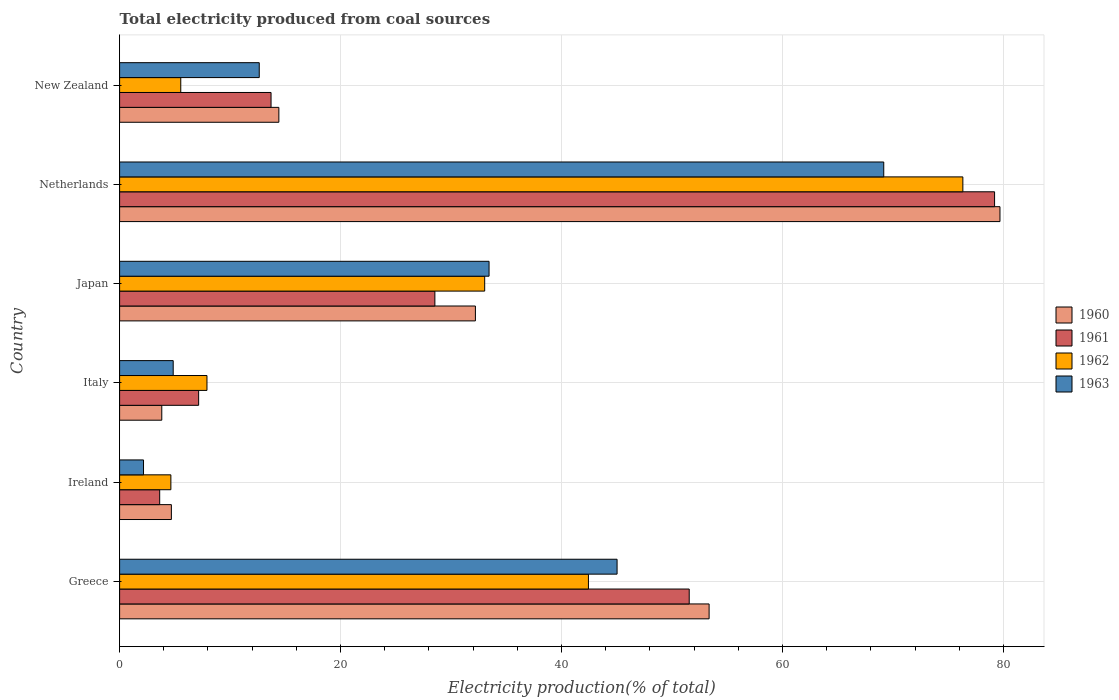Are the number of bars per tick equal to the number of legend labels?
Keep it short and to the point. Yes. Are the number of bars on each tick of the Y-axis equal?
Keep it short and to the point. Yes. How many bars are there on the 6th tick from the top?
Your answer should be very brief. 4. What is the label of the 5th group of bars from the top?
Ensure brevity in your answer.  Ireland. In how many cases, is the number of bars for a given country not equal to the number of legend labels?
Keep it short and to the point. 0. What is the total electricity produced in 1960 in Japan?
Provide a succinct answer. 32.21. Across all countries, what is the maximum total electricity produced in 1961?
Provide a succinct answer. 79.2. Across all countries, what is the minimum total electricity produced in 1961?
Your response must be concise. 3.63. In which country was the total electricity produced in 1960 maximum?
Your answer should be compact. Netherlands. In which country was the total electricity produced in 1960 minimum?
Your answer should be very brief. Italy. What is the total total electricity produced in 1961 in the graph?
Offer a very short reply. 183.8. What is the difference between the total electricity produced in 1961 in Ireland and that in Japan?
Ensure brevity in your answer.  -24.91. What is the difference between the total electricity produced in 1962 in Ireland and the total electricity produced in 1963 in Italy?
Your response must be concise. -0.21. What is the average total electricity produced in 1962 per country?
Keep it short and to the point. 28.32. What is the difference between the total electricity produced in 1961 and total electricity produced in 1963 in New Zealand?
Give a very brief answer. 1.07. In how many countries, is the total electricity produced in 1963 greater than 48 %?
Your answer should be compact. 1. What is the ratio of the total electricity produced in 1962 in Netherlands to that in New Zealand?
Make the answer very short. 13.79. Is the difference between the total electricity produced in 1961 in Greece and Ireland greater than the difference between the total electricity produced in 1963 in Greece and Ireland?
Your response must be concise. Yes. What is the difference between the highest and the second highest total electricity produced in 1961?
Your answer should be very brief. 27.64. What is the difference between the highest and the lowest total electricity produced in 1963?
Keep it short and to the point. 67.01. In how many countries, is the total electricity produced in 1962 greater than the average total electricity produced in 1962 taken over all countries?
Provide a short and direct response. 3. Is it the case that in every country, the sum of the total electricity produced in 1960 and total electricity produced in 1961 is greater than the sum of total electricity produced in 1963 and total electricity produced in 1962?
Ensure brevity in your answer.  No. What does the 3rd bar from the top in Japan represents?
Offer a very short reply. 1961. What does the 1st bar from the bottom in Japan represents?
Offer a very short reply. 1960. Is it the case that in every country, the sum of the total electricity produced in 1962 and total electricity produced in 1961 is greater than the total electricity produced in 1963?
Provide a succinct answer. Yes. How many bars are there?
Your response must be concise. 24. How many countries are there in the graph?
Offer a very short reply. 6. Does the graph contain any zero values?
Provide a short and direct response. No. Does the graph contain grids?
Your response must be concise. Yes. Where does the legend appear in the graph?
Give a very brief answer. Center right. How are the legend labels stacked?
Offer a very short reply. Vertical. What is the title of the graph?
Your answer should be compact. Total electricity produced from coal sources. What is the label or title of the X-axis?
Your answer should be very brief. Electricity production(% of total). What is the label or title of the Y-axis?
Offer a terse response. Country. What is the Electricity production(% of total) in 1960 in Greece?
Keep it short and to the point. 53.36. What is the Electricity production(% of total) of 1961 in Greece?
Make the answer very short. 51.56. What is the Electricity production(% of total) in 1962 in Greece?
Ensure brevity in your answer.  42.44. What is the Electricity production(% of total) of 1963 in Greece?
Keep it short and to the point. 45.03. What is the Electricity production(% of total) of 1960 in Ireland?
Your answer should be compact. 4.69. What is the Electricity production(% of total) in 1961 in Ireland?
Offer a very short reply. 3.63. What is the Electricity production(% of total) of 1962 in Ireland?
Your response must be concise. 4.64. What is the Electricity production(% of total) of 1963 in Ireland?
Keep it short and to the point. 2.16. What is the Electricity production(% of total) in 1960 in Italy?
Make the answer very short. 3.82. What is the Electricity production(% of total) in 1961 in Italy?
Keep it short and to the point. 7.15. What is the Electricity production(% of total) of 1962 in Italy?
Ensure brevity in your answer.  7.91. What is the Electricity production(% of total) in 1963 in Italy?
Your answer should be very brief. 4.85. What is the Electricity production(% of total) in 1960 in Japan?
Your answer should be very brief. 32.21. What is the Electricity production(% of total) of 1961 in Japan?
Give a very brief answer. 28.54. What is the Electricity production(% of total) of 1962 in Japan?
Keep it short and to the point. 33.05. What is the Electricity production(% of total) of 1963 in Japan?
Give a very brief answer. 33.44. What is the Electricity production(% of total) of 1960 in Netherlands?
Keep it short and to the point. 79.69. What is the Electricity production(% of total) in 1961 in Netherlands?
Your response must be concise. 79.2. What is the Electricity production(% of total) in 1962 in Netherlands?
Your response must be concise. 76.33. What is the Electricity production(% of total) of 1963 in Netherlands?
Keep it short and to the point. 69.17. What is the Electricity production(% of total) of 1960 in New Zealand?
Give a very brief answer. 14.42. What is the Electricity production(% of total) in 1961 in New Zealand?
Provide a short and direct response. 13.71. What is the Electricity production(% of total) of 1962 in New Zealand?
Provide a succinct answer. 5.54. What is the Electricity production(% of total) in 1963 in New Zealand?
Your answer should be very brief. 12.64. Across all countries, what is the maximum Electricity production(% of total) of 1960?
Offer a very short reply. 79.69. Across all countries, what is the maximum Electricity production(% of total) of 1961?
Keep it short and to the point. 79.2. Across all countries, what is the maximum Electricity production(% of total) of 1962?
Offer a terse response. 76.33. Across all countries, what is the maximum Electricity production(% of total) of 1963?
Offer a terse response. 69.17. Across all countries, what is the minimum Electricity production(% of total) in 1960?
Keep it short and to the point. 3.82. Across all countries, what is the minimum Electricity production(% of total) in 1961?
Your response must be concise. 3.63. Across all countries, what is the minimum Electricity production(% of total) of 1962?
Keep it short and to the point. 4.64. Across all countries, what is the minimum Electricity production(% of total) of 1963?
Your answer should be very brief. 2.16. What is the total Electricity production(% of total) in 1960 in the graph?
Keep it short and to the point. 188.18. What is the total Electricity production(% of total) of 1961 in the graph?
Provide a succinct answer. 183.8. What is the total Electricity production(% of total) in 1962 in the graph?
Provide a succinct answer. 169.91. What is the total Electricity production(% of total) of 1963 in the graph?
Give a very brief answer. 167.3. What is the difference between the Electricity production(% of total) in 1960 in Greece and that in Ireland?
Your answer should be compact. 48.68. What is the difference between the Electricity production(% of total) in 1961 in Greece and that in Ireland?
Ensure brevity in your answer.  47.93. What is the difference between the Electricity production(% of total) in 1962 in Greece and that in Ireland?
Your answer should be very brief. 37.8. What is the difference between the Electricity production(% of total) of 1963 in Greece and that in Ireland?
Your answer should be compact. 42.87. What is the difference between the Electricity production(% of total) in 1960 in Greece and that in Italy?
Offer a terse response. 49.54. What is the difference between the Electricity production(% of total) in 1961 in Greece and that in Italy?
Your answer should be compact. 44.41. What is the difference between the Electricity production(% of total) of 1962 in Greece and that in Italy?
Offer a very short reply. 34.53. What is the difference between the Electricity production(% of total) of 1963 in Greece and that in Italy?
Your response must be concise. 40.18. What is the difference between the Electricity production(% of total) in 1960 in Greece and that in Japan?
Keep it short and to the point. 21.15. What is the difference between the Electricity production(% of total) in 1961 in Greece and that in Japan?
Ensure brevity in your answer.  23.02. What is the difference between the Electricity production(% of total) in 1962 in Greece and that in Japan?
Offer a terse response. 9.39. What is the difference between the Electricity production(% of total) in 1963 in Greece and that in Japan?
Ensure brevity in your answer.  11.59. What is the difference between the Electricity production(% of total) in 1960 in Greece and that in Netherlands?
Ensure brevity in your answer.  -26.33. What is the difference between the Electricity production(% of total) of 1961 in Greece and that in Netherlands?
Ensure brevity in your answer.  -27.64. What is the difference between the Electricity production(% of total) in 1962 in Greece and that in Netherlands?
Give a very brief answer. -33.89. What is the difference between the Electricity production(% of total) of 1963 in Greece and that in Netherlands?
Make the answer very short. -24.14. What is the difference between the Electricity production(% of total) in 1960 in Greece and that in New Zealand?
Ensure brevity in your answer.  38.95. What is the difference between the Electricity production(% of total) of 1961 in Greece and that in New Zealand?
Offer a terse response. 37.85. What is the difference between the Electricity production(% of total) of 1962 in Greece and that in New Zealand?
Offer a very short reply. 36.9. What is the difference between the Electricity production(% of total) in 1963 in Greece and that in New Zealand?
Give a very brief answer. 32.39. What is the difference between the Electricity production(% of total) in 1960 in Ireland and that in Italy?
Your answer should be compact. 0.87. What is the difference between the Electricity production(% of total) in 1961 in Ireland and that in Italy?
Your response must be concise. -3.53. What is the difference between the Electricity production(% of total) in 1962 in Ireland and that in Italy?
Your answer should be compact. -3.27. What is the difference between the Electricity production(% of total) in 1963 in Ireland and that in Italy?
Provide a short and direct response. -2.69. What is the difference between the Electricity production(% of total) in 1960 in Ireland and that in Japan?
Offer a terse response. -27.52. What is the difference between the Electricity production(% of total) in 1961 in Ireland and that in Japan?
Provide a succinct answer. -24.91. What is the difference between the Electricity production(% of total) of 1962 in Ireland and that in Japan?
Offer a very short reply. -28.41. What is the difference between the Electricity production(% of total) in 1963 in Ireland and that in Japan?
Provide a short and direct response. -31.28. What is the difference between the Electricity production(% of total) of 1960 in Ireland and that in Netherlands?
Your response must be concise. -75.01. What is the difference between the Electricity production(% of total) in 1961 in Ireland and that in Netherlands?
Provide a succinct answer. -75.58. What is the difference between the Electricity production(% of total) of 1962 in Ireland and that in Netherlands?
Your response must be concise. -71.69. What is the difference between the Electricity production(% of total) of 1963 in Ireland and that in Netherlands?
Offer a terse response. -67.01. What is the difference between the Electricity production(% of total) in 1960 in Ireland and that in New Zealand?
Your answer should be compact. -9.73. What is the difference between the Electricity production(% of total) of 1961 in Ireland and that in New Zealand?
Offer a very short reply. -10.08. What is the difference between the Electricity production(% of total) of 1962 in Ireland and that in New Zealand?
Your answer should be very brief. -0.9. What is the difference between the Electricity production(% of total) in 1963 in Ireland and that in New Zealand?
Your response must be concise. -10.48. What is the difference between the Electricity production(% of total) of 1960 in Italy and that in Japan?
Provide a short and direct response. -28.39. What is the difference between the Electricity production(% of total) of 1961 in Italy and that in Japan?
Offer a very short reply. -21.38. What is the difference between the Electricity production(% of total) in 1962 in Italy and that in Japan?
Make the answer very short. -25.14. What is the difference between the Electricity production(% of total) in 1963 in Italy and that in Japan?
Make the answer very short. -28.59. What is the difference between the Electricity production(% of total) in 1960 in Italy and that in Netherlands?
Provide a short and direct response. -75.87. What is the difference between the Electricity production(% of total) in 1961 in Italy and that in Netherlands?
Provide a succinct answer. -72.05. What is the difference between the Electricity production(% of total) of 1962 in Italy and that in Netherlands?
Offer a terse response. -68.42. What is the difference between the Electricity production(% of total) of 1963 in Italy and that in Netherlands?
Your answer should be very brief. -64.32. What is the difference between the Electricity production(% of total) in 1960 in Italy and that in New Zealand?
Offer a very short reply. -10.6. What is the difference between the Electricity production(% of total) of 1961 in Italy and that in New Zealand?
Your response must be concise. -6.55. What is the difference between the Electricity production(% of total) of 1962 in Italy and that in New Zealand?
Your answer should be compact. 2.37. What is the difference between the Electricity production(% of total) of 1963 in Italy and that in New Zealand?
Your response must be concise. -7.79. What is the difference between the Electricity production(% of total) of 1960 in Japan and that in Netherlands?
Provide a succinct answer. -47.48. What is the difference between the Electricity production(% of total) of 1961 in Japan and that in Netherlands?
Give a very brief answer. -50.67. What is the difference between the Electricity production(% of total) in 1962 in Japan and that in Netherlands?
Make the answer very short. -43.28. What is the difference between the Electricity production(% of total) in 1963 in Japan and that in Netherlands?
Offer a very short reply. -35.73. What is the difference between the Electricity production(% of total) of 1960 in Japan and that in New Zealand?
Your response must be concise. 17.79. What is the difference between the Electricity production(% of total) in 1961 in Japan and that in New Zealand?
Ensure brevity in your answer.  14.83. What is the difference between the Electricity production(% of total) in 1962 in Japan and that in New Zealand?
Provide a succinct answer. 27.51. What is the difference between the Electricity production(% of total) in 1963 in Japan and that in New Zealand?
Offer a terse response. 20.8. What is the difference between the Electricity production(% of total) of 1960 in Netherlands and that in New Zealand?
Ensure brevity in your answer.  65.28. What is the difference between the Electricity production(% of total) in 1961 in Netherlands and that in New Zealand?
Your answer should be compact. 65.5. What is the difference between the Electricity production(% of total) of 1962 in Netherlands and that in New Zealand?
Make the answer very short. 70.8. What is the difference between the Electricity production(% of total) of 1963 in Netherlands and that in New Zealand?
Make the answer very short. 56.53. What is the difference between the Electricity production(% of total) in 1960 in Greece and the Electricity production(% of total) in 1961 in Ireland?
Keep it short and to the point. 49.73. What is the difference between the Electricity production(% of total) of 1960 in Greece and the Electricity production(% of total) of 1962 in Ireland?
Keep it short and to the point. 48.72. What is the difference between the Electricity production(% of total) of 1960 in Greece and the Electricity production(% of total) of 1963 in Ireland?
Offer a very short reply. 51.2. What is the difference between the Electricity production(% of total) of 1961 in Greece and the Electricity production(% of total) of 1962 in Ireland?
Offer a very short reply. 46.92. What is the difference between the Electricity production(% of total) of 1961 in Greece and the Electricity production(% of total) of 1963 in Ireland?
Your response must be concise. 49.4. What is the difference between the Electricity production(% of total) in 1962 in Greece and the Electricity production(% of total) in 1963 in Ireland?
Ensure brevity in your answer.  40.27. What is the difference between the Electricity production(% of total) of 1960 in Greece and the Electricity production(% of total) of 1961 in Italy?
Offer a terse response. 46.21. What is the difference between the Electricity production(% of total) of 1960 in Greece and the Electricity production(% of total) of 1962 in Italy?
Offer a very short reply. 45.45. What is the difference between the Electricity production(% of total) of 1960 in Greece and the Electricity production(% of total) of 1963 in Italy?
Offer a terse response. 48.51. What is the difference between the Electricity production(% of total) in 1961 in Greece and the Electricity production(% of total) in 1962 in Italy?
Your response must be concise. 43.65. What is the difference between the Electricity production(% of total) in 1961 in Greece and the Electricity production(% of total) in 1963 in Italy?
Keep it short and to the point. 46.71. What is the difference between the Electricity production(% of total) of 1962 in Greece and the Electricity production(% of total) of 1963 in Italy?
Make the answer very short. 37.59. What is the difference between the Electricity production(% of total) in 1960 in Greece and the Electricity production(% of total) in 1961 in Japan?
Give a very brief answer. 24.82. What is the difference between the Electricity production(% of total) in 1960 in Greece and the Electricity production(% of total) in 1962 in Japan?
Make the answer very short. 20.31. What is the difference between the Electricity production(% of total) of 1960 in Greece and the Electricity production(% of total) of 1963 in Japan?
Offer a terse response. 19.92. What is the difference between the Electricity production(% of total) in 1961 in Greece and the Electricity production(% of total) in 1962 in Japan?
Your answer should be very brief. 18.51. What is the difference between the Electricity production(% of total) in 1961 in Greece and the Electricity production(% of total) in 1963 in Japan?
Make the answer very short. 18.12. What is the difference between the Electricity production(% of total) of 1962 in Greece and the Electricity production(% of total) of 1963 in Japan?
Make the answer very short. 9. What is the difference between the Electricity production(% of total) of 1960 in Greece and the Electricity production(% of total) of 1961 in Netherlands?
Your response must be concise. -25.84. What is the difference between the Electricity production(% of total) in 1960 in Greece and the Electricity production(% of total) in 1962 in Netherlands?
Your answer should be compact. -22.97. What is the difference between the Electricity production(% of total) in 1960 in Greece and the Electricity production(% of total) in 1963 in Netherlands?
Offer a very short reply. -15.81. What is the difference between the Electricity production(% of total) in 1961 in Greece and the Electricity production(% of total) in 1962 in Netherlands?
Make the answer very short. -24.77. What is the difference between the Electricity production(% of total) of 1961 in Greece and the Electricity production(% of total) of 1963 in Netherlands?
Provide a succinct answer. -17.61. What is the difference between the Electricity production(% of total) in 1962 in Greece and the Electricity production(% of total) in 1963 in Netherlands?
Your answer should be very brief. -26.73. What is the difference between the Electricity production(% of total) of 1960 in Greece and the Electricity production(% of total) of 1961 in New Zealand?
Provide a short and direct response. 39.65. What is the difference between the Electricity production(% of total) in 1960 in Greece and the Electricity production(% of total) in 1962 in New Zealand?
Offer a very short reply. 47.83. What is the difference between the Electricity production(% of total) in 1960 in Greece and the Electricity production(% of total) in 1963 in New Zealand?
Your answer should be very brief. 40.72. What is the difference between the Electricity production(% of total) of 1961 in Greece and the Electricity production(% of total) of 1962 in New Zealand?
Give a very brief answer. 46.03. What is the difference between the Electricity production(% of total) of 1961 in Greece and the Electricity production(% of total) of 1963 in New Zealand?
Your answer should be compact. 38.92. What is the difference between the Electricity production(% of total) of 1962 in Greece and the Electricity production(% of total) of 1963 in New Zealand?
Your response must be concise. 29.8. What is the difference between the Electricity production(% of total) in 1960 in Ireland and the Electricity production(% of total) in 1961 in Italy?
Your answer should be compact. -2.47. What is the difference between the Electricity production(% of total) of 1960 in Ireland and the Electricity production(% of total) of 1962 in Italy?
Keep it short and to the point. -3.22. What is the difference between the Electricity production(% of total) of 1960 in Ireland and the Electricity production(% of total) of 1963 in Italy?
Offer a very short reply. -0.17. What is the difference between the Electricity production(% of total) in 1961 in Ireland and the Electricity production(% of total) in 1962 in Italy?
Provide a short and direct response. -4.28. What is the difference between the Electricity production(% of total) of 1961 in Ireland and the Electricity production(% of total) of 1963 in Italy?
Your answer should be compact. -1.22. What is the difference between the Electricity production(% of total) of 1962 in Ireland and the Electricity production(% of total) of 1963 in Italy?
Keep it short and to the point. -0.21. What is the difference between the Electricity production(% of total) in 1960 in Ireland and the Electricity production(% of total) in 1961 in Japan?
Make the answer very short. -23.85. What is the difference between the Electricity production(% of total) of 1960 in Ireland and the Electricity production(% of total) of 1962 in Japan?
Your answer should be compact. -28.36. What is the difference between the Electricity production(% of total) of 1960 in Ireland and the Electricity production(% of total) of 1963 in Japan?
Ensure brevity in your answer.  -28.76. What is the difference between the Electricity production(% of total) of 1961 in Ireland and the Electricity production(% of total) of 1962 in Japan?
Your answer should be very brief. -29.42. What is the difference between the Electricity production(% of total) in 1961 in Ireland and the Electricity production(% of total) in 1963 in Japan?
Offer a terse response. -29.82. What is the difference between the Electricity production(% of total) in 1962 in Ireland and the Electricity production(% of total) in 1963 in Japan?
Your response must be concise. -28.8. What is the difference between the Electricity production(% of total) of 1960 in Ireland and the Electricity production(% of total) of 1961 in Netherlands?
Your answer should be very brief. -74.52. What is the difference between the Electricity production(% of total) in 1960 in Ireland and the Electricity production(% of total) in 1962 in Netherlands?
Offer a terse response. -71.65. What is the difference between the Electricity production(% of total) of 1960 in Ireland and the Electricity production(% of total) of 1963 in Netherlands?
Give a very brief answer. -64.49. What is the difference between the Electricity production(% of total) in 1961 in Ireland and the Electricity production(% of total) in 1962 in Netherlands?
Provide a succinct answer. -72.71. What is the difference between the Electricity production(% of total) of 1961 in Ireland and the Electricity production(% of total) of 1963 in Netherlands?
Ensure brevity in your answer.  -65.54. What is the difference between the Electricity production(% of total) in 1962 in Ireland and the Electricity production(% of total) in 1963 in Netherlands?
Provide a succinct answer. -64.53. What is the difference between the Electricity production(% of total) in 1960 in Ireland and the Electricity production(% of total) in 1961 in New Zealand?
Provide a short and direct response. -9.02. What is the difference between the Electricity production(% of total) of 1960 in Ireland and the Electricity production(% of total) of 1962 in New Zealand?
Provide a short and direct response. -0.85. What is the difference between the Electricity production(% of total) of 1960 in Ireland and the Electricity production(% of total) of 1963 in New Zealand?
Keep it short and to the point. -7.95. What is the difference between the Electricity production(% of total) in 1961 in Ireland and the Electricity production(% of total) in 1962 in New Zealand?
Your answer should be very brief. -1.91. What is the difference between the Electricity production(% of total) in 1961 in Ireland and the Electricity production(% of total) in 1963 in New Zealand?
Your answer should be compact. -9.01. What is the difference between the Electricity production(% of total) in 1962 in Ireland and the Electricity production(% of total) in 1963 in New Zealand?
Ensure brevity in your answer.  -8. What is the difference between the Electricity production(% of total) in 1960 in Italy and the Electricity production(% of total) in 1961 in Japan?
Provide a short and direct response. -24.72. What is the difference between the Electricity production(% of total) in 1960 in Italy and the Electricity production(% of total) in 1962 in Japan?
Ensure brevity in your answer.  -29.23. What is the difference between the Electricity production(% of total) in 1960 in Italy and the Electricity production(% of total) in 1963 in Japan?
Your response must be concise. -29.63. What is the difference between the Electricity production(% of total) in 1961 in Italy and the Electricity production(% of total) in 1962 in Japan?
Give a very brief answer. -25.89. What is the difference between the Electricity production(% of total) of 1961 in Italy and the Electricity production(% of total) of 1963 in Japan?
Your answer should be compact. -26.29. What is the difference between the Electricity production(% of total) of 1962 in Italy and the Electricity production(% of total) of 1963 in Japan?
Ensure brevity in your answer.  -25.53. What is the difference between the Electricity production(% of total) in 1960 in Italy and the Electricity production(% of total) in 1961 in Netherlands?
Provide a short and direct response. -75.39. What is the difference between the Electricity production(% of total) in 1960 in Italy and the Electricity production(% of total) in 1962 in Netherlands?
Provide a succinct answer. -72.51. What is the difference between the Electricity production(% of total) of 1960 in Italy and the Electricity production(% of total) of 1963 in Netherlands?
Ensure brevity in your answer.  -65.35. What is the difference between the Electricity production(% of total) in 1961 in Italy and the Electricity production(% of total) in 1962 in Netherlands?
Ensure brevity in your answer.  -69.18. What is the difference between the Electricity production(% of total) of 1961 in Italy and the Electricity production(% of total) of 1963 in Netherlands?
Provide a succinct answer. -62.02. What is the difference between the Electricity production(% of total) in 1962 in Italy and the Electricity production(% of total) in 1963 in Netherlands?
Your response must be concise. -61.26. What is the difference between the Electricity production(% of total) of 1960 in Italy and the Electricity production(% of total) of 1961 in New Zealand?
Make the answer very short. -9.89. What is the difference between the Electricity production(% of total) of 1960 in Italy and the Electricity production(% of total) of 1962 in New Zealand?
Make the answer very short. -1.72. What is the difference between the Electricity production(% of total) of 1960 in Italy and the Electricity production(% of total) of 1963 in New Zealand?
Ensure brevity in your answer.  -8.82. What is the difference between the Electricity production(% of total) in 1961 in Italy and the Electricity production(% of total) in 1962 in New Zealand?
Ensure brevity in your answer.  1.62. What is the difference between the Electricity production(% of total) in 1961 in Italy and the Electricity production(% of total) in 1963 in New Zealand?
Give a very brief answer. -5.49. What is the difference between the Electricity production(% of total) of 1962 in Italy and the Electricity production(% of total) of 1963 in New Zealand?
Ensure brevity in your answer.  -4.73. What is the difference between the Electricity production(% of total) of 1960 in Japan and the Electricity production(% of total) of 1961 in Netherlands?
Provide a succinct answer. -47. What is the difference between the Electricity production(% of total) of 1960 in Japan and the Electricity production(% of total) of 1962 in Netherlands?
Ensure brevity in your answer.  -44.13. What is the difference between the Electricity production(% of total) in 1960 in Japan and the Electricity production(% of total) in 1963 in Netherlands?
Your answer should be very brief. -36.96. What is the difference between the Electricity production(% of total) in 1961 in Japan and the Electricity production(% of total) in 1962 in Netherlands?
Keep it short and to the point. -47.79. What is the difference between the Electricity production(% of total) in 1961 in Japan and the Electricity production(% of total) in 1963 in Netherlands?
Offer a very short reply. -40.63. What is the difference between the Electricity production(% of total) in 1962 in Japan and the Electricity production(% of total) in 1963 in Netherlands?
Ensure brevity in your answer.  -36.12. What is the difference between the Electricity production(% of total) of 1960 in Japan and the Electricity production(% of total) of 1961 in New Zealand?
Provide a short and direct response. 18.5. What is the difference between the Electricity production(% of total) in 1960 in Japan and the Electricity production(% of total) in 1962 in New Zealand?
Your answer should be very brief. 26.67. What is the difference between the Electricity production(% of total) of 1960 in Japan and the Electricity production(% of total) of 1963 in New Zealand?
Offer a very short reply. 19.57. What is the difference between the Electricity production(% of total) in 1961 in Japan and the Electricity production(% of total) in 1962 in New Zealand?
Provide a short and direct response. 23. What is the difference between the Electricity production(% of total) of 1961 in Japan and the Electricity production(% of total) of 1963 in New Zealand?
Offer a very short reply. 15.9. What is the difference between the Electricity production(% of total) in 1962 in Japan and the Electricity production(% of total) in 1963 in New Zealand?
Your answer should be compact. 20.41. What is the difference between the Electricity production(% of total) in 1960 in Netherlands and the Electricity production(% of total) in 1961 in New Zealand?
Your answer should be very brief. 65.98. What is the difference between the Electricity production(% of total) of 1960 in Netherlands and the Electricity production(% of total) of 1962 in New Zealand?
Offer a very short reply. 74.16. What is the difference between the Electricity production(% of total) in 1960 in Netherlands and the Electricity production(% of total) in 1963 in New Zealand?
Give a very brief answer. 67.05. What is the difference between the Electricity production(% of total) in 1961 in Netherlands and the Electricity production(% of total) in 1962 in New Zealand?
Your answer should be very brief. 73.67. What is the difference between the Electricity production(% of total) of 1961 in Netherlands and the Electricity production(% of total) of 1963 in New Zealand?
Keep it short and to the point. 66.56. What is the difference between the Electricity production(% of total) of 1962 in Netherlands and the Electricity production(% of total) of 1963 in New Zealand?
Give a very brief answer. 63.69. What is the average Electricity production(% of total) in 1960 per country?
Offer a very short reply. 31.36. What is the average Electricity production(% of total) of 1961 per country?
Your answer should be very brief. 30.63. What is the average Electricity production(% of total) of 1962 per country?
Offer a terse response. 28.32. What is the average Electricity production(% of total) of 1963 per country?
Give a very brief answer. 27.88. What is the difference between the Electricity production(% of total) of 1960 and Electricity production(% of total) of 1961 in Greece?
Provide a short and direct response. 1.8. What is the difference between the Electricity production(% of total) in 1960 and Electricity production(% of total) in 1962 in Greece?
Provide a succinct answer. 10.92. What is the difference between the Electricity production(% of total) of 1960 and Electricity production(% of total) of 1963 in Greece?
Offer a very short reply. 8.33. What is the difference between the Electricity production(% of total) of 1961 and Electricity production(% of total) of 1962 in Greece?
Give a very brief answer. 9.12. What is the difference between the Electricity production(% of total) of 1961 and Electricity production(% of total) of 1963 in Greece?
Give a very brief answer. 6.53. What is the difference between the Electricity production(% of total) in 1962 and Electricity production(% of total) in 1963 in Greece?
Your answer should be compact. -2.59. What is the difference between the Electricity production(% of total) of 1960 and Electricity production(% of total) of 1961 in Ireland?
Make the answer very short. 1.06. What is the difference between the Electricity production(% of total) in 1960 and Electricity production(% of total) in 1962 in Ireland?
Offer a very short reply. 0.05. What is the difference between the Electricity production(% of total) in 1960 and Electricity production(% of total) in 1963 in Ireland?
Your answer should be compact. 2.52. What is the difference between the Electricity production(% of total) in 1961 and Electricity production(% of total) in 1962 in Ireland?
Make the answer very short. -1.01. What is the difference between the Electricity production(% of total) in 1961 and Electricity production(% of total) in 1963 in Ireland?
Offer a very short reply. 1.46. What is the difference between the Electricity production(% of total) of 1962 and Electricity production(% of total) of 1963 in Ireland?
Offer a very short reply. 2.48. What is the difference between the Electricity production(% of total) of 1960 and Electricity production(% of total) of 1961 in Italy?
Provide a succinct answer. -3.34. What is the difference between the Electricity production(% of total) of 1960 and Electricity production(% of total) of 1962 in Italy?
Your answer should be compact. -4.09. What is the difference between the Electricity production(% of total) of 1960 and Electricity production(% of total) of 1963 in Italy?
Your answer should be compact. -1.03. What is the difference between the Electricity production(% of total) in 1961 and Electricity production(% of total) in 1962 in Italy?
Offer a terse response. -0.75. What is the difference between the Electricity production(% of total) in 1961 and Electricity production(% of total) in 1963 in Italy?
Your answer should be compact. 2.3. What is the difference between the Electricity production(% of total) in 1962 and Electricity production(% of total) in 1963 in Italy?
Your answer should be compact. 3.06. What is the difference between the Electricity production(% of total) of 1960 and Electricity production(% of total) of 1961 in Japan?
Offer a terse response. 3.67. What is the difference between the Electricity production(% of total) of 1960 and Electricity production(% of total) of 1962 in Japan?
Ensure brevity in your answer.  -0.84. What is the difference between the Electricity production(% of total) in 1960 and Electricity production(% of total) in 1963 in Japan?
Your answer should be compact. -1.24. What is the difference between the Electricity production(% of total) in 1961 and Electricity production(% of total) in 1962 in Japan?
Provide a succinct answer. -4.51. What is the difference between the Electricity production(% of total) of 1961 and Electricity production(% of total) of 1963 in Japan?
Give a very brief answer. -4.9. What is the difference between the Electricity production(% of total) in 1962 and Electricity production(% of total) in 1963 in Japan?
Provide a succinct answer. -0.4. What is the difference between the Electricity production(% of total) of 1960 and Electricity production(% of total) of 1961 in Netherlands?
Provide a succinct answer. 0.49. What is the difference between the Electricity production(% of total) of 1960 and Electricity production(% of total) of 1962 in Netherlands?
Offer a terse response. 3.36. What is the difference between the Electricity production(% of total) of 1960 and Electricity production(% of total) of 1963 in Netherlands?
Offer a very short reply. 10.52. What is the difference between the Electricity production(% of total) in 1961 and Electricity production(% of total) in 1962 in Netherlands?
Your answer should be compact. 2.87. What is the difference between the Electricity production(% of total) of 1961 and Electricity production(% of total) of 1963 in Netherlands?
Offer a very short reply. 10.03. What is the difference between the Electricity production(% of total) of 1962 and Electricity production(% of total) of 1963 in Netherlands?
Ensure brevity in your answer.  7.16. What is the difference between the Electricity production(% of total) of 1960 and Electricity production(% of total) of 1961 in New Zealand?
Your response must be concise. 0.71. What is the difference between the Electricity production(% of total) of 1960 and Electricity production(% of total) of 1962 in New Zealand?
Your answer should be very brief. 8.88. What is the difference between the Electricity production(% of total) of 1960 and Electricity production(% of total) of 1963 in New Zealand?
Ensure brevity in your answer.  1.78. What is the difference between the Electricity production(% of total) of 1961 and Electricity production(% of total) of 1962 in New Zealand?
Your answer should be very brief. 8.17. What is the difference between the Electricity production(% of total) in 1961 and Electricity production(% of total) in 1963 in New Zealand?
Keep it short and to the point. 1.07. What is the difference between the Electricity production(% of total) of 1962 and Electricity production(% of total) of 1963 in New Zealand?
Keep it short and to the point. -7.1. What is the ratio of the Electricity production(% of total) of 1960 in Greece to that in Ireland?
Provide a short and direct response. 11.39. What is the ratio of the Electricity production(% of total) in 1961 in Greece to that in Ireland?
Your answer should be very brief. 14.21. What is the ratio of the Electricity production(% of total) in 1962 in Greece to that in Ireland?
Offer a terse response. 9.14. What is the ratio of the Electricity production(% of total) of 1963 in Greece to that in Ireland?
Offer a very short reply. 20.8. What is the ratio of the Electricity production(% of total) in 1960 in Greece to that in Italy?
Make the answer very short. 13.97. What is the ratio of the Electricity production(% of total) of 1961 in Greece to that in Italy?
Keep it short and to the point. 7.21. What is the ratio of the Electricity production(% of total) of 1962 in Greece to that in Italy?
Give a very brief answer. 5.37. What is the ratio of the Electricity production(% of total) in 1963 in Greece to that in Italy?
Your answer should be very brief. 9.28. What is the ratio of the Electricity production(% of total) of 1960 in Greece to that in Japan?
Offer a very short reply. 1.66. What is the ratio of the Electricity production(% of total) of 1961 in Greece to that in Japan?
Provide a short and direct response. 1.81. What is the ratio of the Electricity production(% of total) of 1962 in Greece to that in Japan?
Provide a short and direct response. 1.28. What is the ratio of the Electricity production(% of total) of 1963 in Greece to that in Japan?
Ensure brevity in your answer.  1.35. What is the ratio of the Electricity production(% of total) in 1960 in Greece to that in Netherlands?
Your answer should be compact. 0.67. What is the ratio of the Electricity production(% of total) in 1961 in Greece to that in Netherlands?
Your answer should be very brief. 0.65. What is the ratio of the Electricity production(% of total) in 1962 in Greece to that in Netherlands?
Provide a succinct answer. 0.56. What is the ratio of the Electricity production(% of total) in 1963 in Greece to that in Netherlands?
Provide a short and direct response. 0.65. What is the ratio of the Electricity production(% of total) in 1960 in Greece to that in New Zealand?
Ensure brevity in your answer.  3.7. What is the ratio of the Electricity production(% of total) of 1961 in Greece to that in New Zealand?
Keep it short and to the point. 3.76. What is the ratio of the Electricity production(% of total) of 1962 in Greece to that in New Zealand?
Your response must be concise. 7.67. What is the ratio of the Electricity production(% of total) in 1963 in Greece to that in New Zealand?
Your answer should be compact. 3.56. What is the ratio of the Electricity production(% of total) of 1960 in Ireland to that in Italy?
Provide a succinct answer. 1.23. What is the ratio of the Electricity production(% of total) of 1961 in Ireland to that in Italy?
Your answer should be very brief. 0.51. What is the ratio of the Electricity production(% of total) of 1962 in Ireland to that in Italy?
Give a very brief answer. 0.59. What is the ratio of the Electricity production(% of total) in 1963 in Ireland to that in Italy?
Your response must be concise. 0.45. What is the ratio of the Electricity production(% of total) in 1960 in Ireland to that in Japan?
Give a very brief answer. 0.15. What is the ratio of the Electricity production(% of total) of 1961 in Ireland to that in Japan?
Offer a terse response. 0.13. What is the ratio of the Electricity production(% of total) in 1962 in Ireland to that in Japan?
Give a very brief answer. 0.14. What is the ratio of the Electricity production(% of total) in 1963 in Ireland to that in Japan?
Your response must be concise. 0.06. What is the ratio of the Electricity production(% of total) in 1960 in Ireland to that in Netherlands?
Give a very brief answer. 0.06. What is the ratio of the Electricity production(% of total) in 1961 in Ireland to that in Netherlands?
Give a very brief answer. 0.05. What is the ratio of the Electricity production(% of total) of 1962 in Ireland to that in Netherlands?
Ensure brevity in your answer.  0.06. What is the ratio of the Electricity production(% of total) in 1963 in Ireland to that in Netherlands?
Provide a short and direct response. 0.03. What is the ratio of the Electricity production(% of total) of 1960 in Ireland to that in New Zealand?
Your response must be concise. 0.33. What is the ratio of the Electricity production(% of total) in 1961 in Ireland to that in New Zealand?
Your answer should be very brief. 0.26. What is the ratio of the Electricity production(% of total) in 1962 in Ireland to that in New Zealand?
Make the answer very short. 0.84. What is the ratio of the Electricity production(% of total) in 1963 in Ireland to that in New Zealand?
Make the answer very short. 0.17. What is the ratio of the Electricity production(% of total) in 1960 in Italy to that in Japan?
Provide a succinct answer. 0.12. What is the ratio of the Electricity production(% of total) in 1961 in Italy to that in Japan?
Give a very brief answer. 0.25. What is the ratio of the Electricity production(% of total) in 1962 in Italy to that in Japan?
Ensure brevity in your answer.  0.24. What is the ratio of the Electricity production(% of total) in 1963 in Italy to that in Japan?
Your response must be concise. 0.15. What is the ratio of the Electricity production(% of total) of 1960 in Italy to that in Netherlands?
Offer a very short reply. 0.05. What is the ratio of the Electricity production(% of total) in 1961 in Italy to that in Netherlands?
Give a very brief answer. 0.09. What is the ratio of the Electricity production(% of total) in 1962 in Italy to that in Netherlands?
Provide a succinct answer. 0.1. What is the ratio of the Electricity production(% of total) in 1963 in Italy to that in Netherlands?
Your answer should be compact. 0.07. What is the ratio of the Electricity production(% of total) of 1960 in Italy to that in New Zealand?
Provide a short and direct response. 0.26. What is the ratio of the Electricity production(% of total) in 1961 in Italy to that in New Zealand?
Provide a succinct answer. 0.52. What is the ratio of the Electricity production(% of total) of 1962 in Italy to that in New Zealand?
Keep it short and to the point. 1.43. What is the ratio of the Electricity production(% of total) in 1963 in Italy to that in New Zealand?
Your answer should be very brief. 0.38. What is the ratio of the Electricity production(% of total) in 1960 in Japan to that in Netherlands?
Offer a terse response. 0.4. What is the ratio of the Electricity production(% of total) in 1961 in Japan to that in Netherlands?
Provide a succinct answer. 0.36. What is the ratio of the Electricity production(% of total) of 1962 in Japan to that in Netherlands?
Provide a succinct answer. 0.43. What is the ratio of the Electricity production(% of total) of 1963 in Japan to that in Netherlands?
Keep it short and to the point. 0.48. What is the ratio of the Electricity production(% of total) of 1960 in Japan to that in New Zealand?
Your response must be concise. 2.23. What is the ratio of the Electricity production(% of total) of 1961 in Japan to that in New Zealand?
Provide a succinct answer. 2.08. What is the ratio of the Electricity production(% of total) in 1962 in Japan to that in New Zealand?
Your answer should be very brief. 5.97. What is the ratio of the Electricity production(% of total) of 1963 in Japan to that in New Zealand?
Make the answer very short. 2.65. What is the ratio of the Electricity production(% of total) in 1960 in Netherlands to that in New Zealand?
Your answer should be compact. 5.53. What is the ratio of the Electricity production(% of total) of 1961 in Netherlands to that in New Zealand?
Offer a very short reply. 5.78. What is the ratio of the Electricity production(% of total) in 1962 in Netherlands to that in New Zealand?
Ensure brevity in your answer.  13.79. What is the ratio of the Electricity production(% of total) in 1963 in Netherlands to that in New Zealand?
Make the answer very short. 5.47. What is the difference between the highest and the second highest Electricity production(% of total) in 1960?
Your response must be concise. 26.33. What is the difference between the highest and the second highest Electricity production(% of total) in 1961?
Provide a succinct answer. 27.64. What is the difference between the highest and the second highest Electricity production(% of total) in 1962?
Your answer should be very brief. 33.89. What is the difference between the highest and the second highest Electricity production(% of total) in 1963?
Provide a short and direct response. 24.14. What is the difference between the highest and the lowest Electricity production(% of total) in 1960?
Your response must be concise. 75.87. What is the difference between the highest and the lowest Electricity production(% of total) of 1961?
Give a very brief answer. 75.58. What is the difference between the highest and the lowest Electricity production(% of total) of 1962?
Ensure brevity in your answer.  71.69. What is the difference between the highest and the lowest Electricity production(% of total) of 1963?
Offer a very short reply. 67.01. 